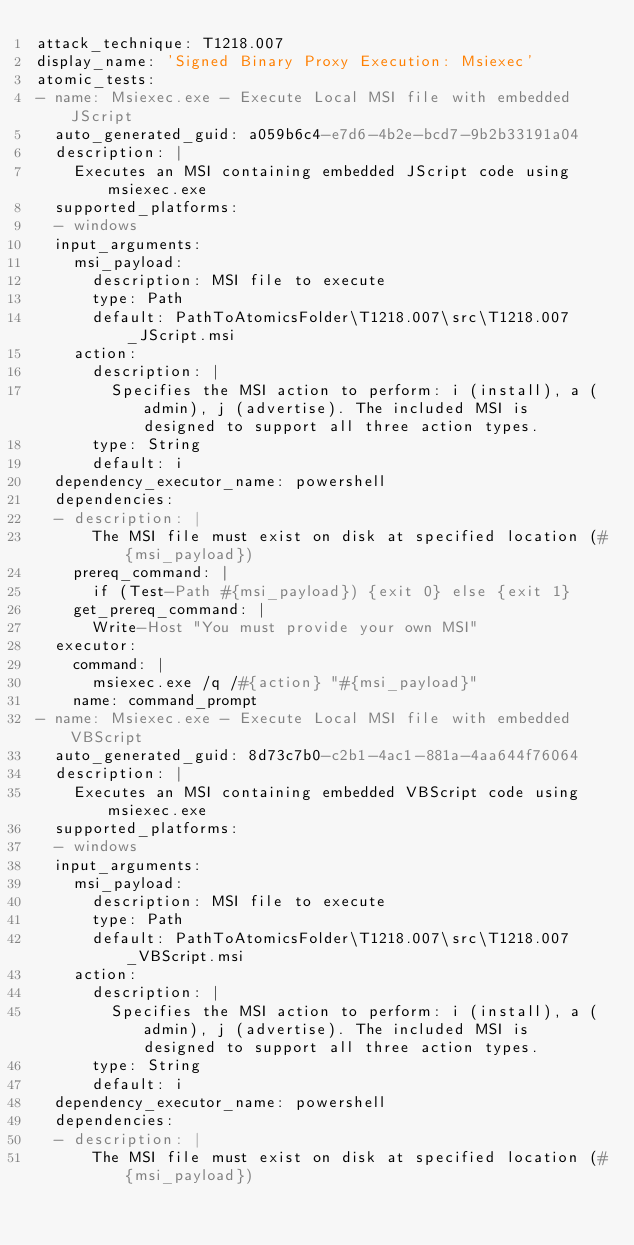Convert code to text. <code><loc_0><loc_0><loc_500><loc_500><_YAML_>attack_technique: T1218.007
display_name: 'Signed Binary Proxy Execution: Msiexec'
atomic_tests:
- name: Msiexec.exe - Execute Local MSI file with embedded JScript
  auto_generated_guid: a059b6c4-e7d6-4b2e-bcd7-9b2b33191a04
  description: |
    Executes an MSI containing embedded JScript code using msiexec.exe
  supported_platforms:
  - windows
  input_arguments:
    msi_payload:
      description: MSI file to execute
      type: Path
      default: PathToAtomicsFolder\T1218.007\src\T1218.007_JScript.msi
    action:
      description: |
        Specifies the MSI action to perform: i (install), a (admin), j (advertise). The included MSI is designed to support all three action types.
      type: String
      default: i
  dependency_executor_name: powershell
  dependencies:
  - description: |
      The MSI file must exist on disk at specified location (#{msi_payload})
    prereq_command: |
      if (Test-Path #{msi_payload}) {exit 0} else {exit 1}
    get_prereq_command: |
      Write-Host "You must provide your own MSI"
  executor:
    command: |
      msiexec.exe /q /#{action} "#{msi_payload}"
    name: command_prompt
- name: Msiexec.exe - Execute Local MSI file with embedded VBScript
  auto_generated_guid: 8d73c7b0-c2b1-4ac1-881a-4aa644f76064
  description: |
    Executes an MSI containing embedded VBScript code using msiexec.exe
  supported_platforms:
  - windows
  input_arguments:
    msi_payload:
      description: MSI file to execute
      type: Path
      default: PathToAtomicsFolder\T1218.007\src\T1218.007_VBScript.msi
    action:
      description: |
        Specifies the MSI action to perform: i (install), a (admin), j (advertise). The included MSI is designed to support all three action types.
      type: String
      default: i
  dependency_executor_name: powershell
  dependencies:
  - description: |
      The MSI file must exist on disk at specified location (#{msi_payload})</code> 